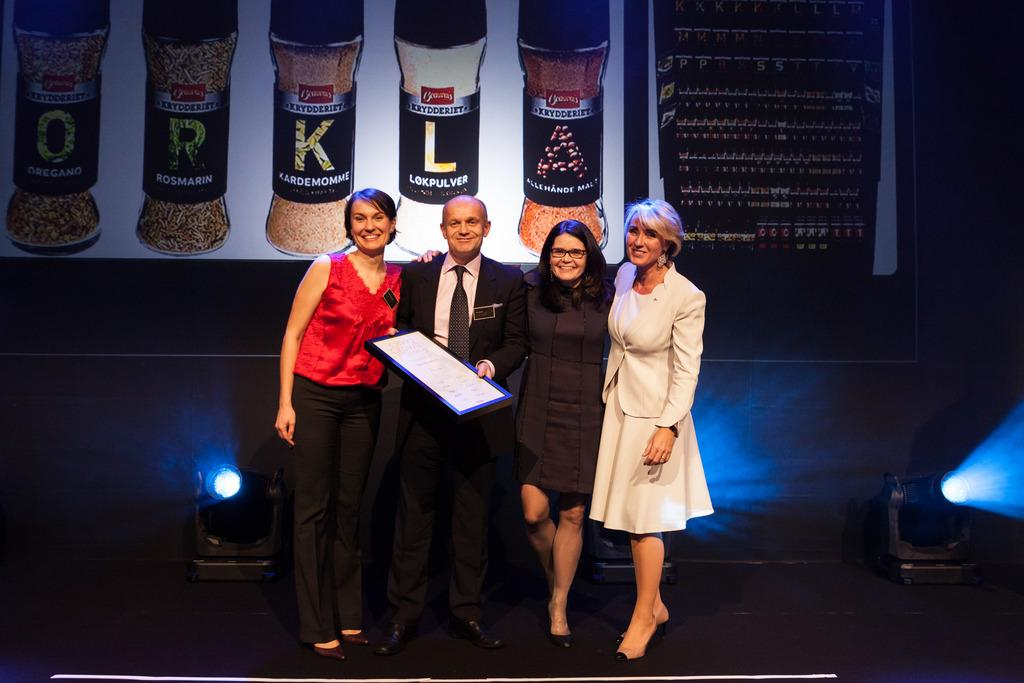What are the people in the image doing? The people in the image are standing and smiling. Can you describe any objects that the people are holding? One person is holding a frame. What type of lighting is visible in the image? Focusing lights are visible in the image. What is present in the background of the image? There is a banner in the background of the image, and the background is dark. How many lizards can be seen crawling on the banner in the image? There are no lizards present in the image; the banner is the only visible object in the background. Are there any women in the image? The provided facts do not specify the gender of the people in the image, so we cannot definitively answer whether there are any women present. 